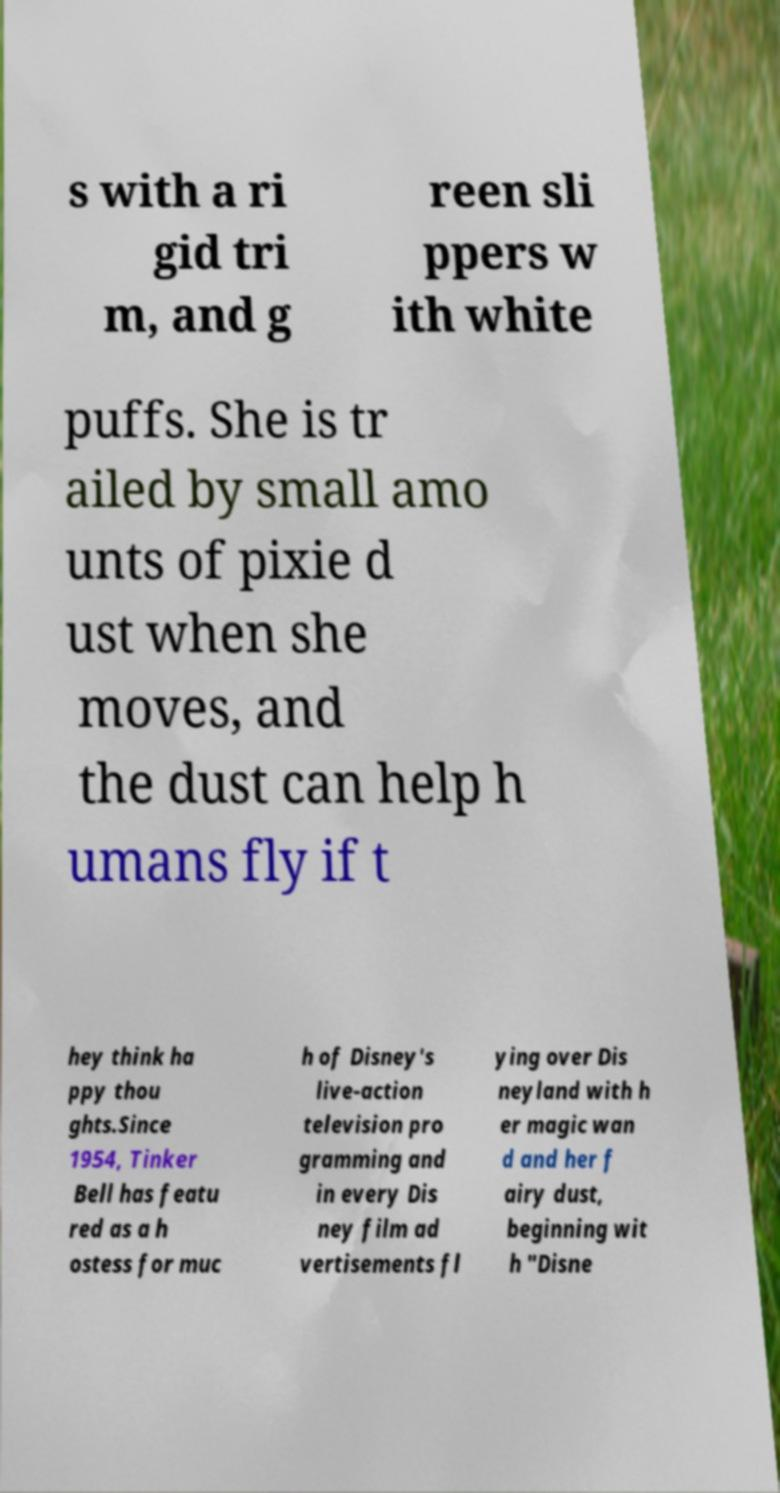Please identify and transcribe the text found in this image. s with a ri gid tri m, and g reen sli ppers w ith white puffs. She is tr ailed by small amo unts of pixie d ust when she moves, and the dust can help h umans fly if t hey think ha ppy thou ghts.Since 1954, Tinker Bell has featu red as a h ostess for muc h of Disney's live-action television pro gramming and in every Dis ney film ad vertisements fl ying over Dis neyland with h er magic wan d and her f airy dust, beginning wit h "Disne 